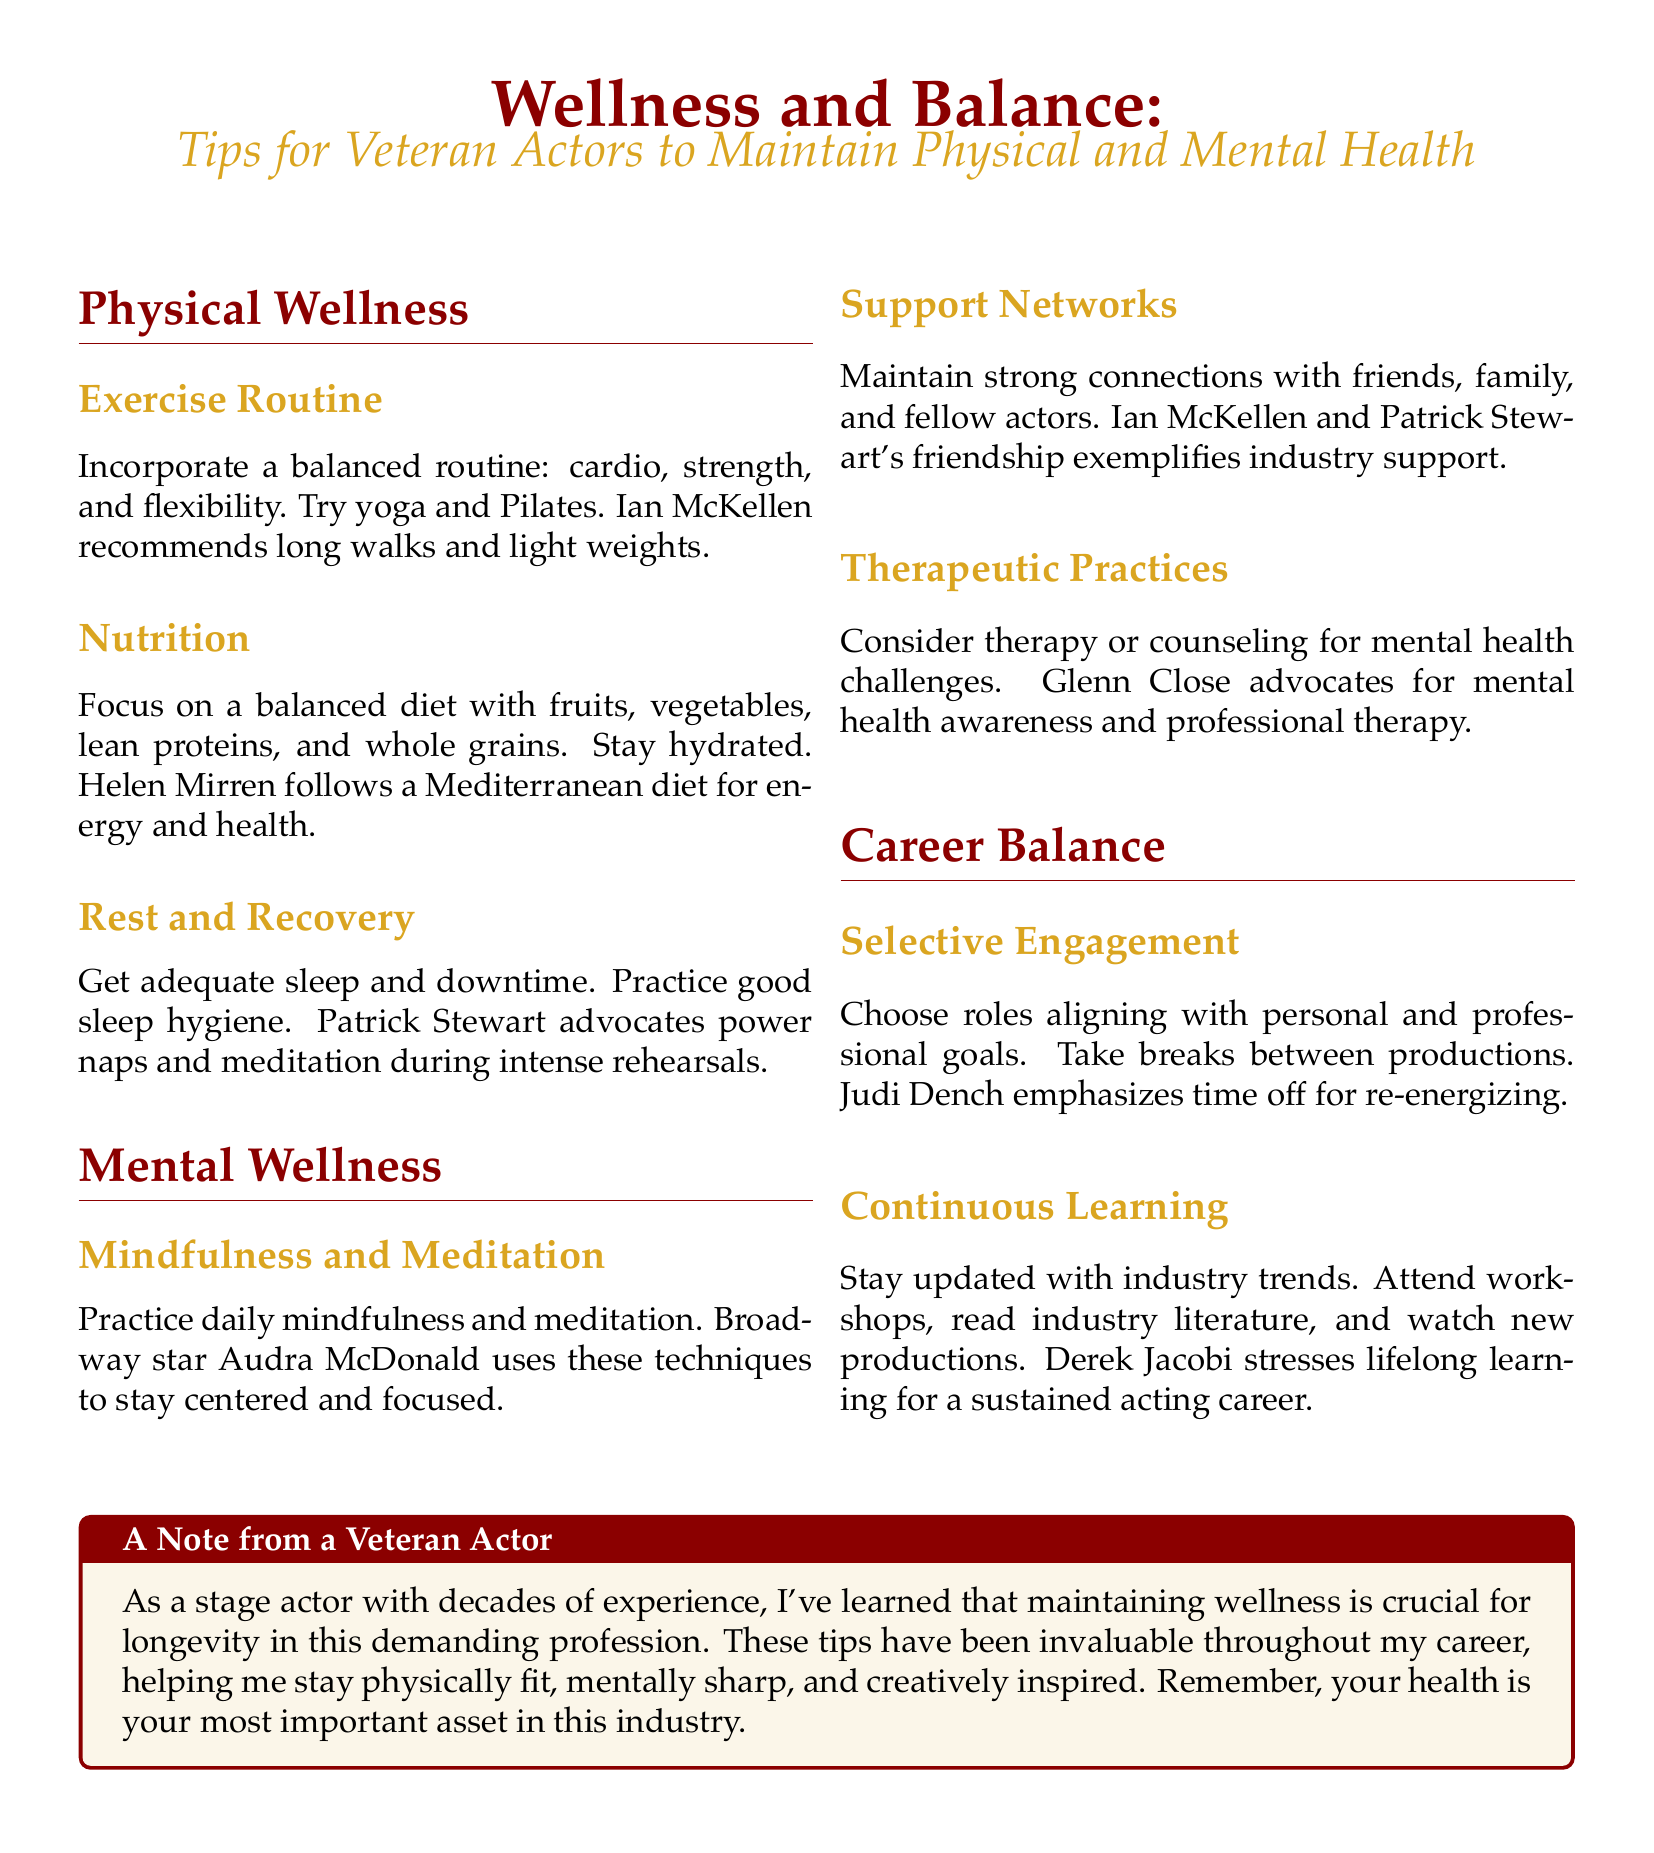What is the focus of the document? The document provides guidance on wellness and balance specifically for veteran actors, emphasizing physical and mental health.
Answer: Wellness and Balance Who recommends yoga and Pilates? The document states that a balanced exercise routine can include yoga and Pilates and mentions Ian McKellen in context with exercise recommendations.
Answer: Ian McKellen What diet does Helen Mirren follow? The document mentions Helen Mirren's approach to nutrition, highlighting her preference for the Mediterranean diet.
Answer: Mediterranean diet Which actor endorses power naps? The document states that Patrick Stewart advocates for power naps and meditation, especially during intense rehearsals.
Answer: Patrick Stewart What key practice does Audra McDonald use for mental wellness? The document indicates that daily mindfulness and meditation are practices Audra McDonald uses to maintain mental wellness.
Answer: Mindfulness and meditation What is emphasized by Judi Dench about career balance? The document mentions that Judi Dench emphasizes the importance of taking time off to re-energize between productions.
Answer: Time off What is one thing Derek Jacobi stresses for sustaining an acting career? The document indicates that Derek Jacobi stresses the importance of continuous learning and staying updated with industry trends.
Answer: Lifelong learning Which therapeutic practice is suggested for mental health challenges? The document suggests considering therapy or counseling as a practice for addressing mental health challenges.
Answer: Therapy What color is used for the section titles in the document? The document describes the color of the section titles as deep red.
Answer: Deep red 